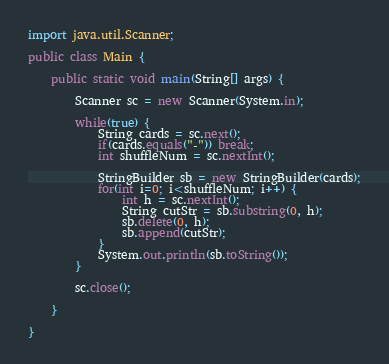<code> <loc_0><loc_0><loc_500><loc_500><_Java_>import java.util.Scanner;

public class Main {

	public static void main(String[] args) {

		Scanner sc = new Scanner(System.in);

		while(true) {
			String cards = sc.next();
			if(cards.equals("-")) break;
			int shuffleNum = sc.nextInt();

			StringBuilder sb = new StringBuilder(cards);
			for(int i=0; i<shuffleNum; i++) {
				int h = sc.nextInt();
				String cutStr = sb.substring(0, h);
				sb.delete(0, h);
				sb.append(cutStr);
			}
			System.out.println(sb.toString());
		}

		sc.close();

	}

}
</code> 